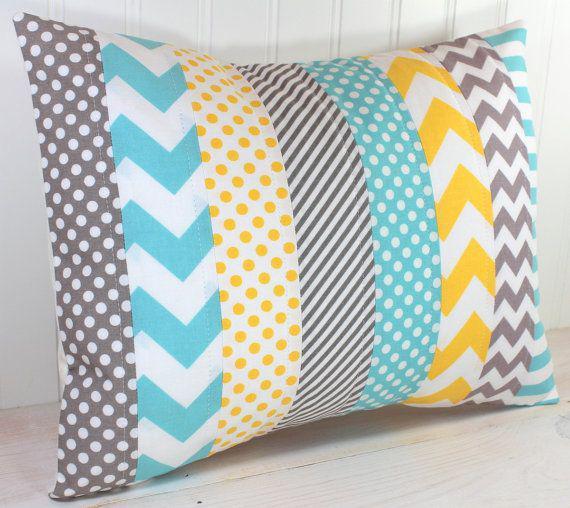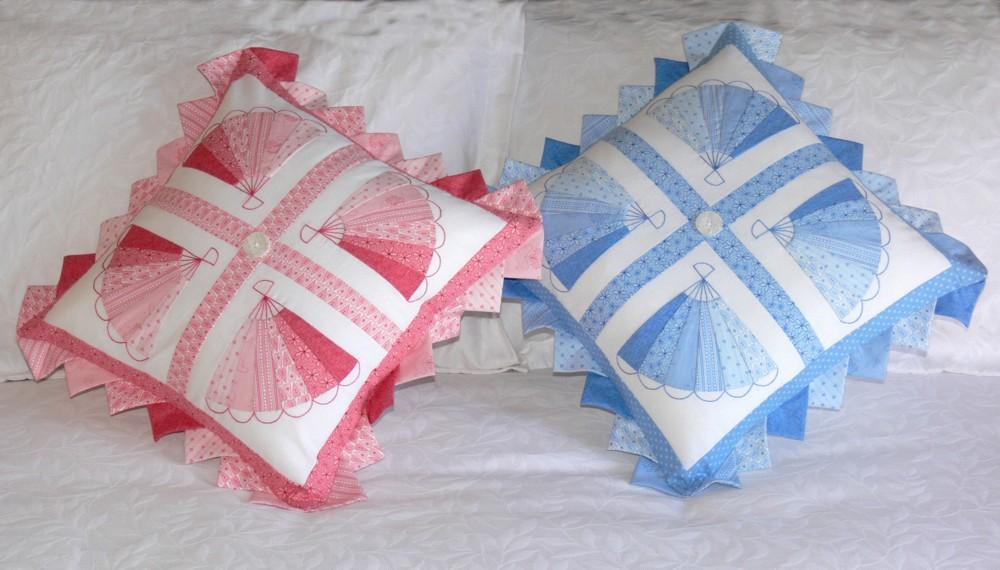The first image is the image on the left, the second image is the image on the right. Given the left and right images, does the statement "The left and right image contains the same number of quilted piece of fabric." hold true? Answer yes or no. No. The first image is the image on the left, the second image is the image on the right. Examine the images to the left and right. Is the description "One pillow has a vertical stripe pattern." accurate? Answer yes or no. Yes. 